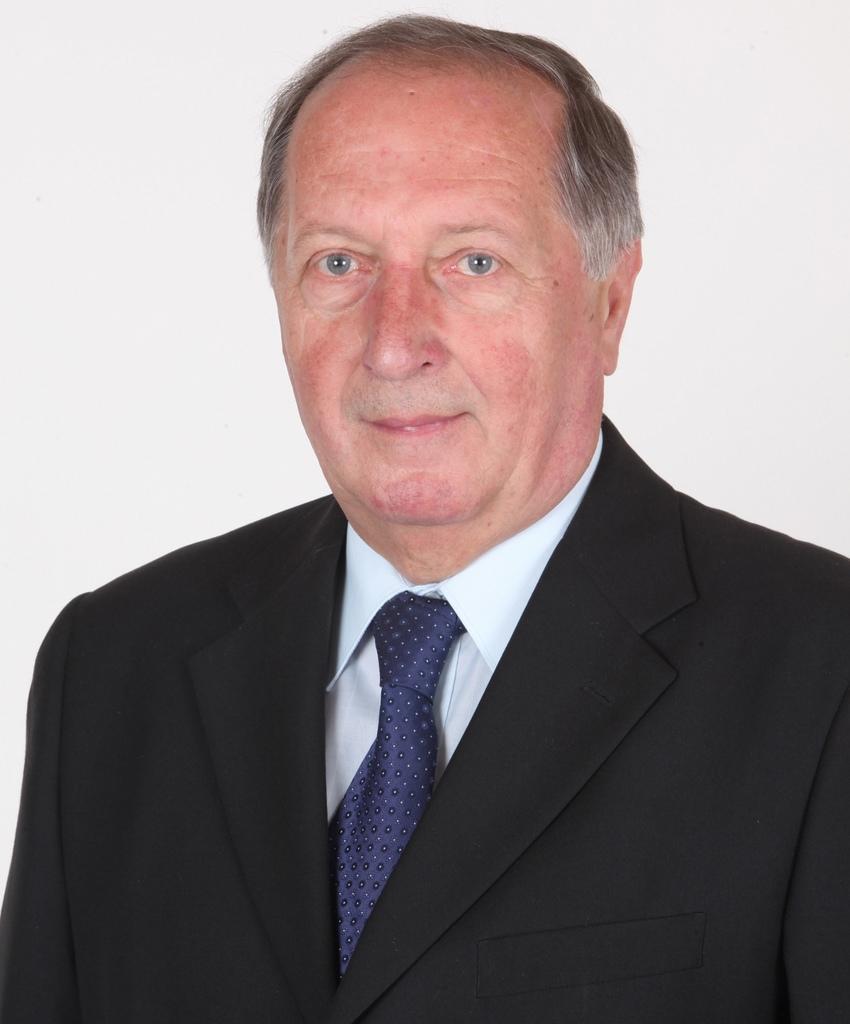How would you summarize this image in a sentence or two? In the picture I can see a man who is wearing a shirt, a tie and a coat. The background of the image is white in color. 